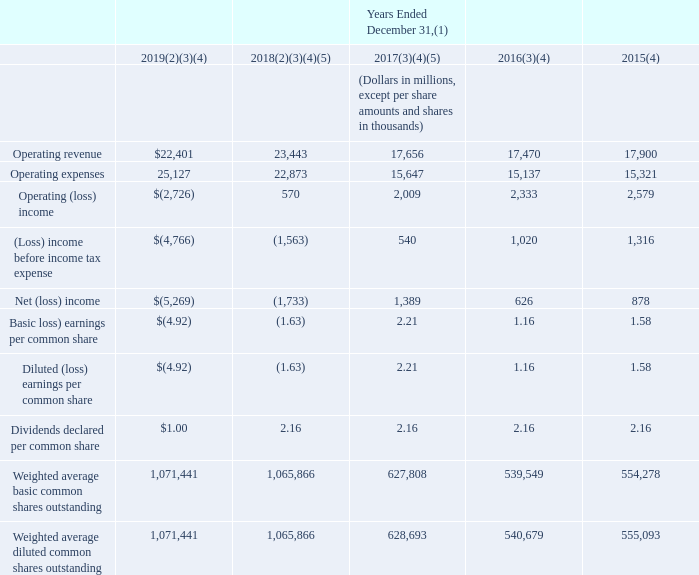ITEM 6. SELECTED FINANCIAL DATA
The following tables of selected consolidated financial data should be read in conjunction with, and are qualified by reference to, our consolidated financial statements and notes thereto in Item 8 of Part II and “Management’s Discussion and Analysis of Financial Condition and Results of Operations” in Item 7 of Part II of this report.
The tables of selected financial data shown below are derived from our audited consolidated financial statements, which include the operating results, cash flows and financial condition of Level 3 beginning November 1, 2017. These historical results are not necessarily indicative of results that you can expect for any future period.
The following table summarizes selected financial information from our consolidated statements of operations.
(1) See “Management’s Discussion and Analysis of Financial Condition and Results of Operations—Results of Operations” in Item 7 of Part II of this report and in our preceding annual reports on Form 10-K for a discussion of unusual items affecting the results for each of the years presented.
(2) During 2019 and 2018, we recorded non-cash, non-tax-deductible goodwill impairment charges of $6.5 billion and $2.7 billion, respectively.
(3) During 2019, 2018, 2017 and 2016, we incurred Level 3 acquisition-related expenses of $234 million, $393 million, $271 million and $52 million, respectively. For additional information, see “Management’s Discussion and Analysis of Financial Condition and Results of Operations—Acquisition of Level 3” and Note 2—Acquisition of Level 3 to our consolidated financial statements in Item 8 of Part II of this report.
(4) During 2019, 2018, 2017, 2016 and 2015, we recognized an incremental $157 million, $171 million, $186 million, $201 million and $215 million, respectively, of revenue associated with the Federal Communications Commission (“FCC”) Connect America Fund Phase II support program, as compared to revenue received under the previous interstate USF program.
(5) The enactment of the Tax Cuts and Jobs Act in December 2017 resulted in a re-measurement of our deferred tax assets and liabilities at the new federal corporate tax rate of 21%. The re-measurement resulted in tax expense of $92 million for 2018 and a tax benefit of approximately $1.1 billion for 2017.
What is the amount of incremental operating revenue earned in 2017? $186 million. What is the new federal corporate tax rate in 2017? 21%. What types of expenses were recorded during 2018? Non-cash, non-tax-deductible goodwill impairment charges, level 3 acquisition-related expenses, tax expense. What is the sum of non-cash, non-tax-deductible goodwill impairment charges for 2019 and 2018?
Answer scale should be: billion. $6.5 billion + $2.7 billion 
Answer: 9.2. Which year has the lowest operating expenses? $15,137<$15,321<$15,647<$22,873<$25,127
Answer: 2016. What is the average non-cash, non-tax-deductible goodwill impairment charge in 2018 and 2019?
Answer scale should be: billion. (6.5+2.7)/2
Answer: 4.6. 